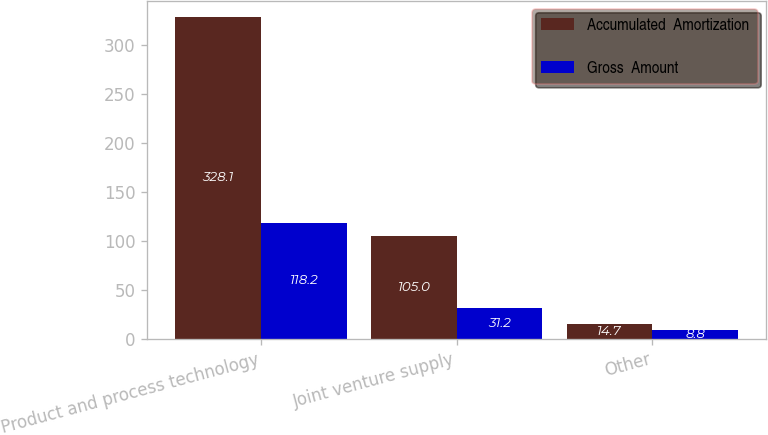Convert chart. <chart><loc_0><loc_0><loc_500><loc_500><stacked_bar_chart><ecel><fcel>Product and process technology<fcel>Joint venture supply<fcel>Other<nl><fcel>Accumulated  Amortization<fcel>328.1<fcel>105<fcel>14.7<nl><fcel>Gross  Amount<fcel>118.2<fcel>31.2<fcel>8.8<nl></chart> 